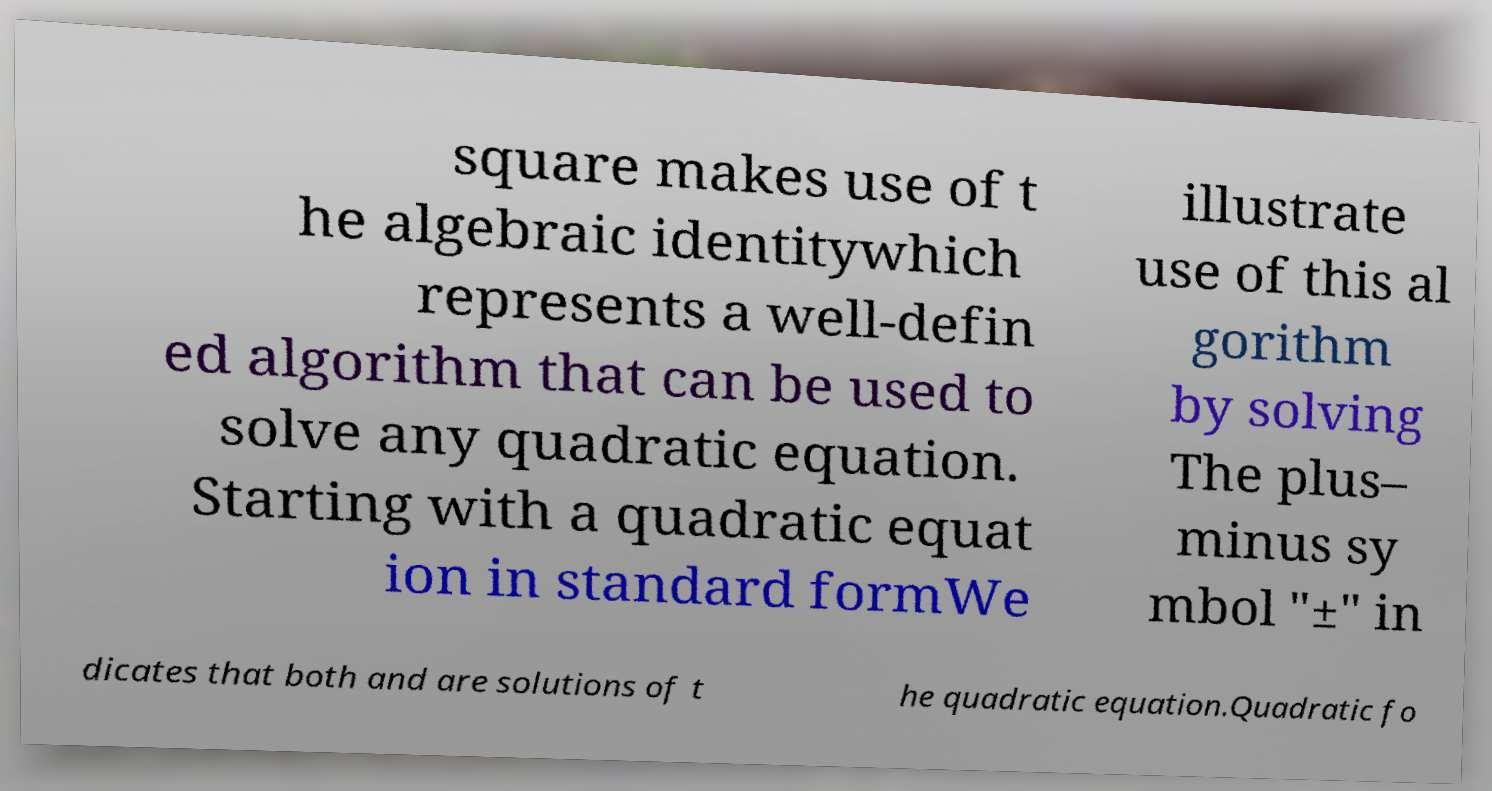I need the written content from this picture converted into text. Can you do that? square makes use of t he algebraic identitywhich represents a well-defin ed algorithm that can be used to solve any quadratic equation. Starting with a quadratic equat ion in standard formWe illustrate use of this al gorithm by solving The plus– minus sy mbol "±" in dicates that both and are solutions of t he quadratic equation.Quadratic fo 